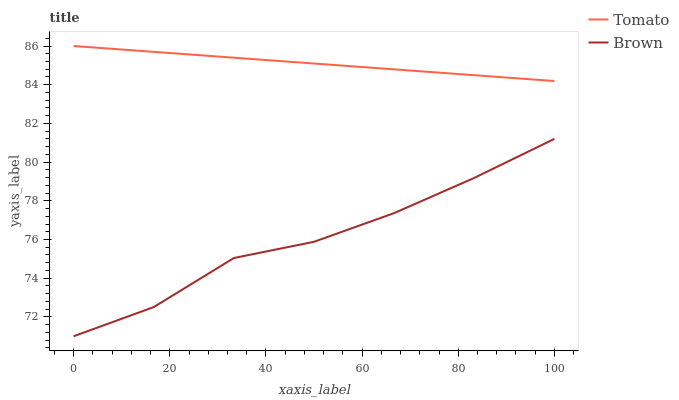Does Brown have the minimum area under the curve?
Answer yes or no. Yes. Does Tomato have the maximum area under the curve?
Answer yes or no. Yes. Does Brown have the maximum area under the curve?
Answer yes or no. No. Is Tomato the smoothest?
Answer yes or no. Yes. Is Brown the roughest?
Answer yes or no. Yes. Is Brown the smoothest?
Answer yes or no. No. Does Brown have the lowest value?
Answer yes or no. Yes. Does Tomato have the highest value?
Answer yes or no. Yes. Does Brown have the highest value?
Answer yes or no. No. Is Brown less than Tomato?
Answer yes or no. Yes. Is Tomato greater than Brown?
Answer yes or no. Yes. Does Brown intersect Tomato?
Answer yes or no. No. 